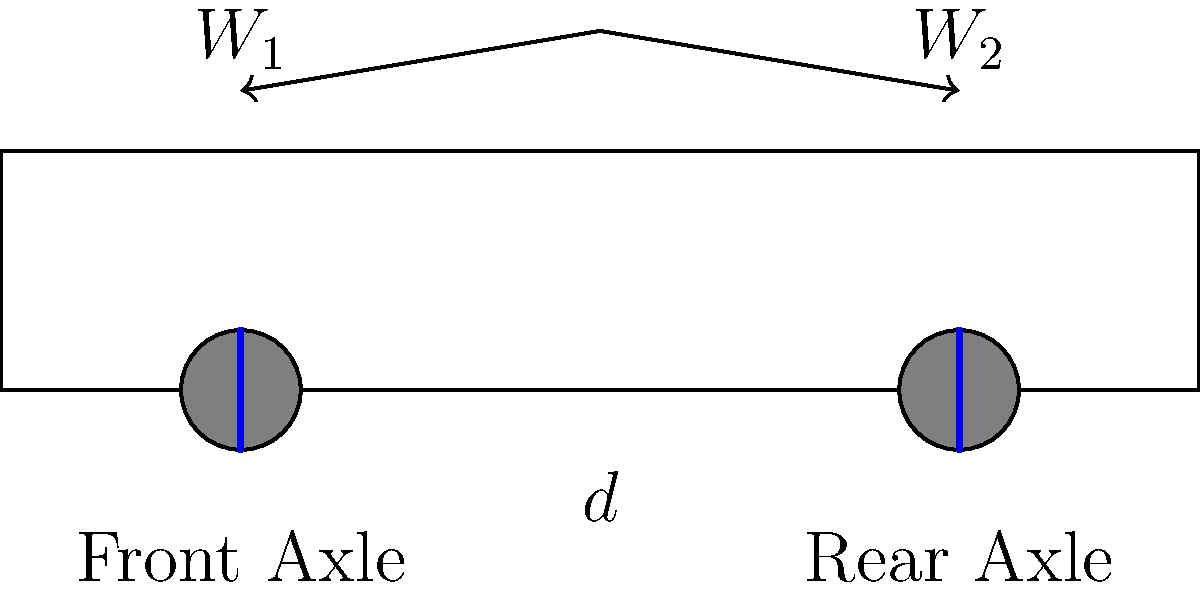A two-axle truck has a total weight of 30,000 kg. The distance between the front and rear axles is 6 meters. If the weight on the front axle ($W_1$) is 10,000 kg, what is the weight on the rear axle ($W_2$)? Assume the truck's center of gravity is located 4 meters from the front axle. To solve this problem, we'll use the principle of moments and the concept of load distribution:

1. Total weight of the truck: $W_{total} = 30,000$ kg
2. Weight on the front axle: $W_1 = 10,000$ kg
3. Distance between axles: $d = 6$ meters
4. Distance of center of gravity from front axle: $x = 4$ meters

Step 1: Calculate the weight on the rear axle ($W_2$):
$W_{total} = W_1 + W_2$
$30,000 = 10,000 + W_2$
$W_2 = 30,000 - 10,000 = 20,000$ kg

Step 2: Verify using the principle of moments:
Sum of moments about the front axle should equal zero:
$W_{total} \cdot x = W_2 \cdot d$

$(30,000 \text{ kg}) \cdot (4 \text{ m}) = (20,000 \text{ kg}) \cdot (6 \text{ m})$
$120,000 \text{ kg·m} = 120,000 \text{ kg·m}$

The equation balances, confirming our calculation for $W_2$.
Answer: 20,000 kg 